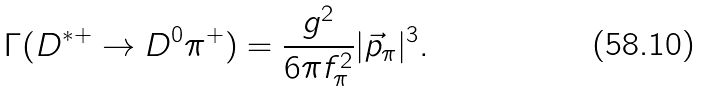<formula> <loc_0><loc_0><loc_500><loc_500>\Gamma ( D ^ { * + } \to D ^ { 0 } \pi ^ { + } ) = \frac { g ^ { 2 } } { 6 \pi f _ { \pi } ^ { 2 } } | { \vec { p } _ { \pi } } | ^ { 3 } .</formula> 